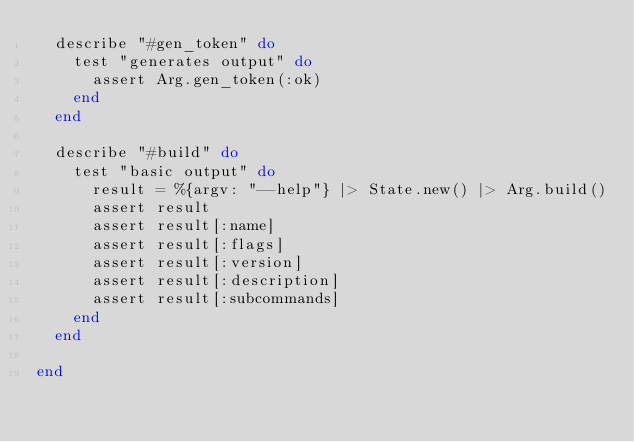Convert code to text. <code><loc_0><loc_0><loc_500><loc_500><_Elixir_>  describe "#gen_token" do
    test "generates output" do
      assert Arg.gen_token(:ok)
    end
  end

  describe "#build" do
    test "basic output" do
      result = %{argv: "--help"} |> State.new() |> Arg.build()
      assert result 
      assert result[:name]
      assert result[:flags]
      assert result[:version]
      assert result[:description]
      assert result[:subcommands]
    end
  end

end
</code> 